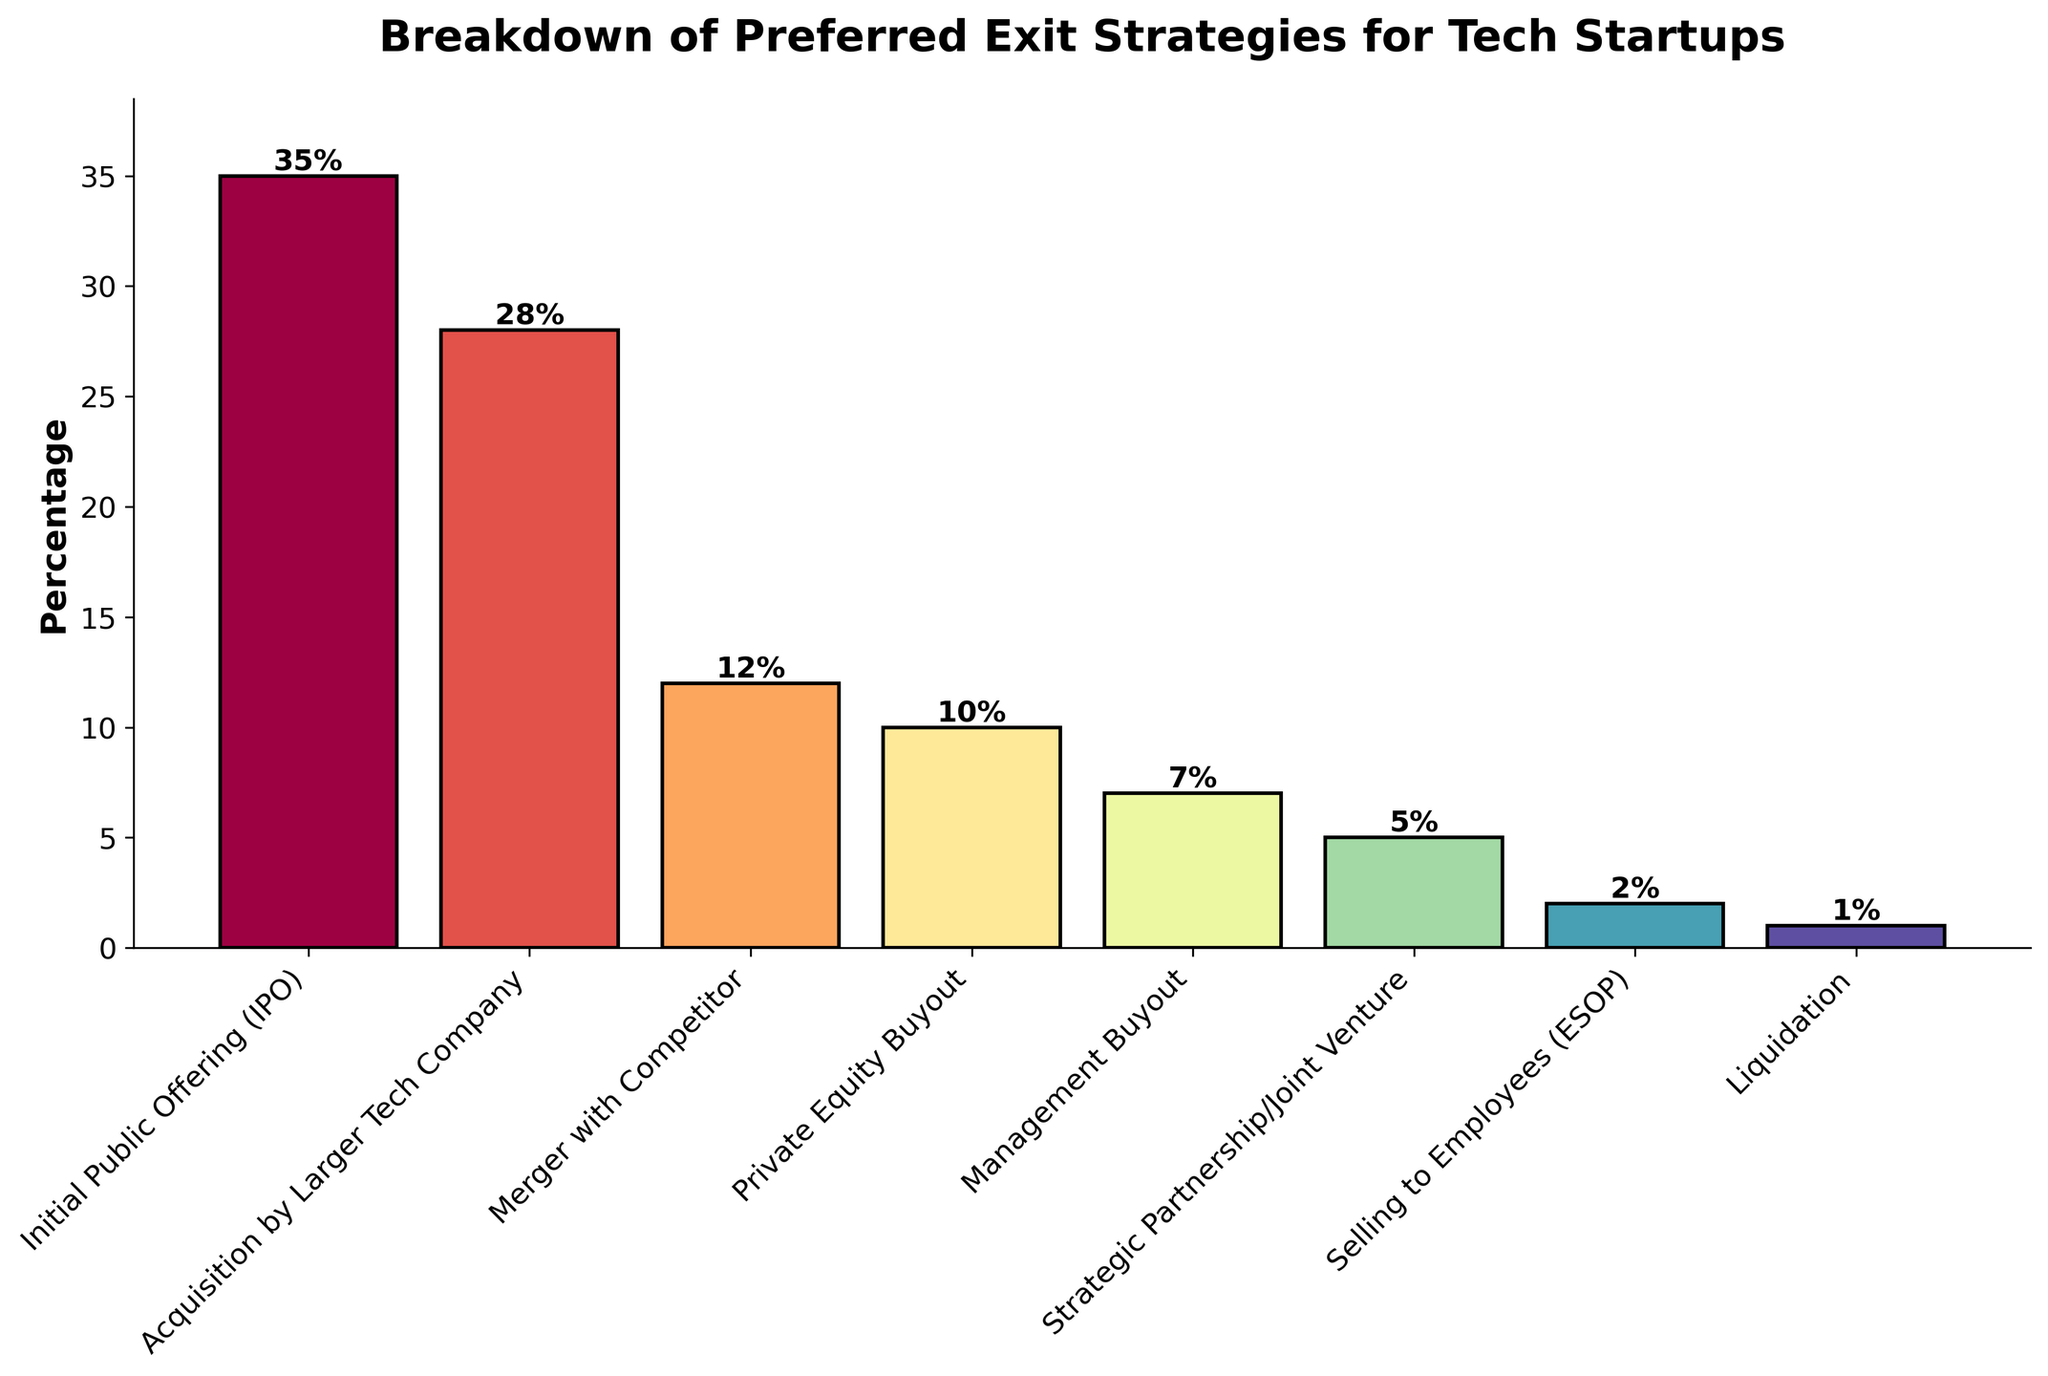Which exit strategy has the highest percentage of preference? Observe the height of the bars representing each exit strategy. The 'Initial Public Offering (IPO)' bar is the tallest.
Answer: Initial Public Offering (IPO) Which exit strategy is the least preferred by tech startups? Identify the bar with the smallest height. The 'Liquidation' bar is the shortest.
Answer: Liquidation How much more popular is IPO compared to Private Equity Buyout? Note the percentages of both strategies: IPO (35%) and Private Equity Buyout (10%). Subtract the smaller percentage from the larger percentage: 35% - 10% = 25%.
Answer: 25% What is the total percentage of startups preferring either Acquisition by Larger Tech Company or Merger with Competitor? Add the percentages of the two strategies: Acquisition by Larger Tech Company (28%) and Merger with Competitor (12%). 28% + 12% = 40%.
Answer: 40% Which two exit strategies combined make up a total of 10%? Find the strategies whose percentages add up to 10%. 'Management Buyout' (7%) and 'Strategic Partnership/Joint Venture' (5%) add up to 12%, 'Selling to Employees (ESOP)' (2%) and 'Liquidation' (1%) add up to 3%, so none match exactly 10%.
Answer: None Does the combined preference for Acquisition by Larger Tech Company and IPO exceed 50%? Calculate the sum of the percentages of Acquisition by Larger Tech Company (28%) and IPO (35%): 28% + 35% = 63%. Since 63% > 50%, the combined preference exceeds 50%.
Answer: Yes What is the combined percentage for strategies with less than 10% preference each? Sum the percentages of the strategies with less than 10% preference: Management Buyout (7%), Strategic Partnership/Joint Venture (5%), Selling to Employees (ESOP) (2%), and Liquidation (1%). 7% + 5% + 2% + 1% = 15%.
Answer: 15% List the strategies in decreasing order of preference. Arrange the percentages in decreasing order: 35% (IPO), 28% (Acquisition by Larger Tech Company), 12% (Merger with Competitor), 10% (Private Equity Buyout), 7% (Management Buyout), 5% (Strategic Partnership/Joint Venture), 2% (Selling to Employees), 1% (Liquidation).
Answer: IPO, Acquisition by Larger Tech Company, Merger with Competitor, Private Equity Buyout, Management Buyout, Strategic Partnership/Joint Venture, Selling to Employees, Liquidation By what factor is the percentage preference for IPO greater than the percentage preference for Selling to Employees? Divide the percentage of IPO by the percentage of Selling to Employees: 35% / 2% = 17.5.
Answer: 17.5 Which exit strategy has a visual representation closest in color to the midpoint of the spectrum? The colors gradate from light to dark. The bar for Merger with Competitor appears to be around the midpoint of the color spectrum.
Answer: Merger with Competitor 